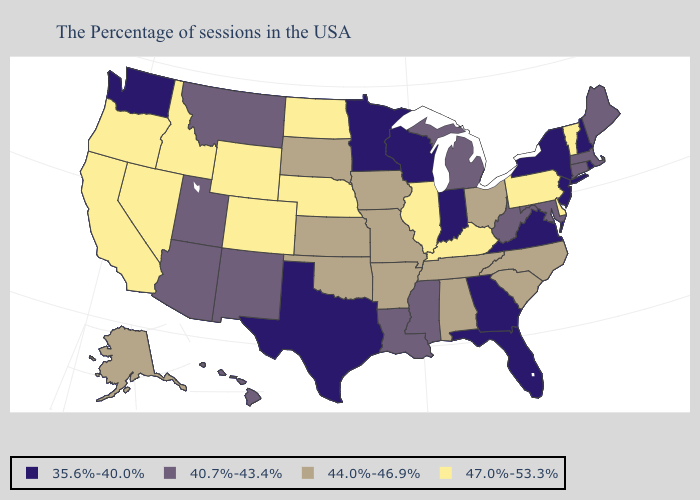Name the states that have a value in the range 47.0%-53.3%?
Write a very short answer. Vermont, Delaware, Pennsylvania, Kentucky, Illinois, Nebraska, North Dakota, Wyoming, Colorado, Idaho, Nevada, California, Oregon. Name the states that have a value in the range 47.0%-53.3%?
Give a very brief answer. Vermont, Delaware, Pennsylvania, Kentucky, Illinois, Nebraska, North Dakota, Wyoming, Colorado, Idaho, Nevada, California, Oregon. Does Vermont have the highest value in the Northeast?
Be succinct. Yes. Does Delaware have a higher value than Mississippi?
Give a very brief answer. Yes. Does the map have missing data?
Answer briefly. No. Does Maryland have a lower value than Connecticut?
Concise answer only. No. Which states have the lowest value in the West?
Be succinct. Washington. Which states have the highest value in the USA?
Concise answer only. Vermont, Delaware, Pennsylvania, Kentucky, Illinois, Nebraska, North Dakota, Wyoming, Colorado, Idaho, Nevada, California, Oregon. What is the value of Utah?
Be succinct. 40.7%-43.4%. Does Alaska have a higher value than Maryland?
Concise answer only. Yes. Name the states that have a value in the range 40.7%-43.4%?
Be succinct. Maine, Massachusetts, Connecticut, Maryland, West Virginia, Michigan, Mississippi, Louisiana, New Mexico, Utah, Montana, Arizona, Hawaii. Does Iowa have a higher value than Mississippi?
Answer briefly. Yes. What is the lowest value in states that border Mississippi?
Keep it brief. 40.7%-43.4%. 